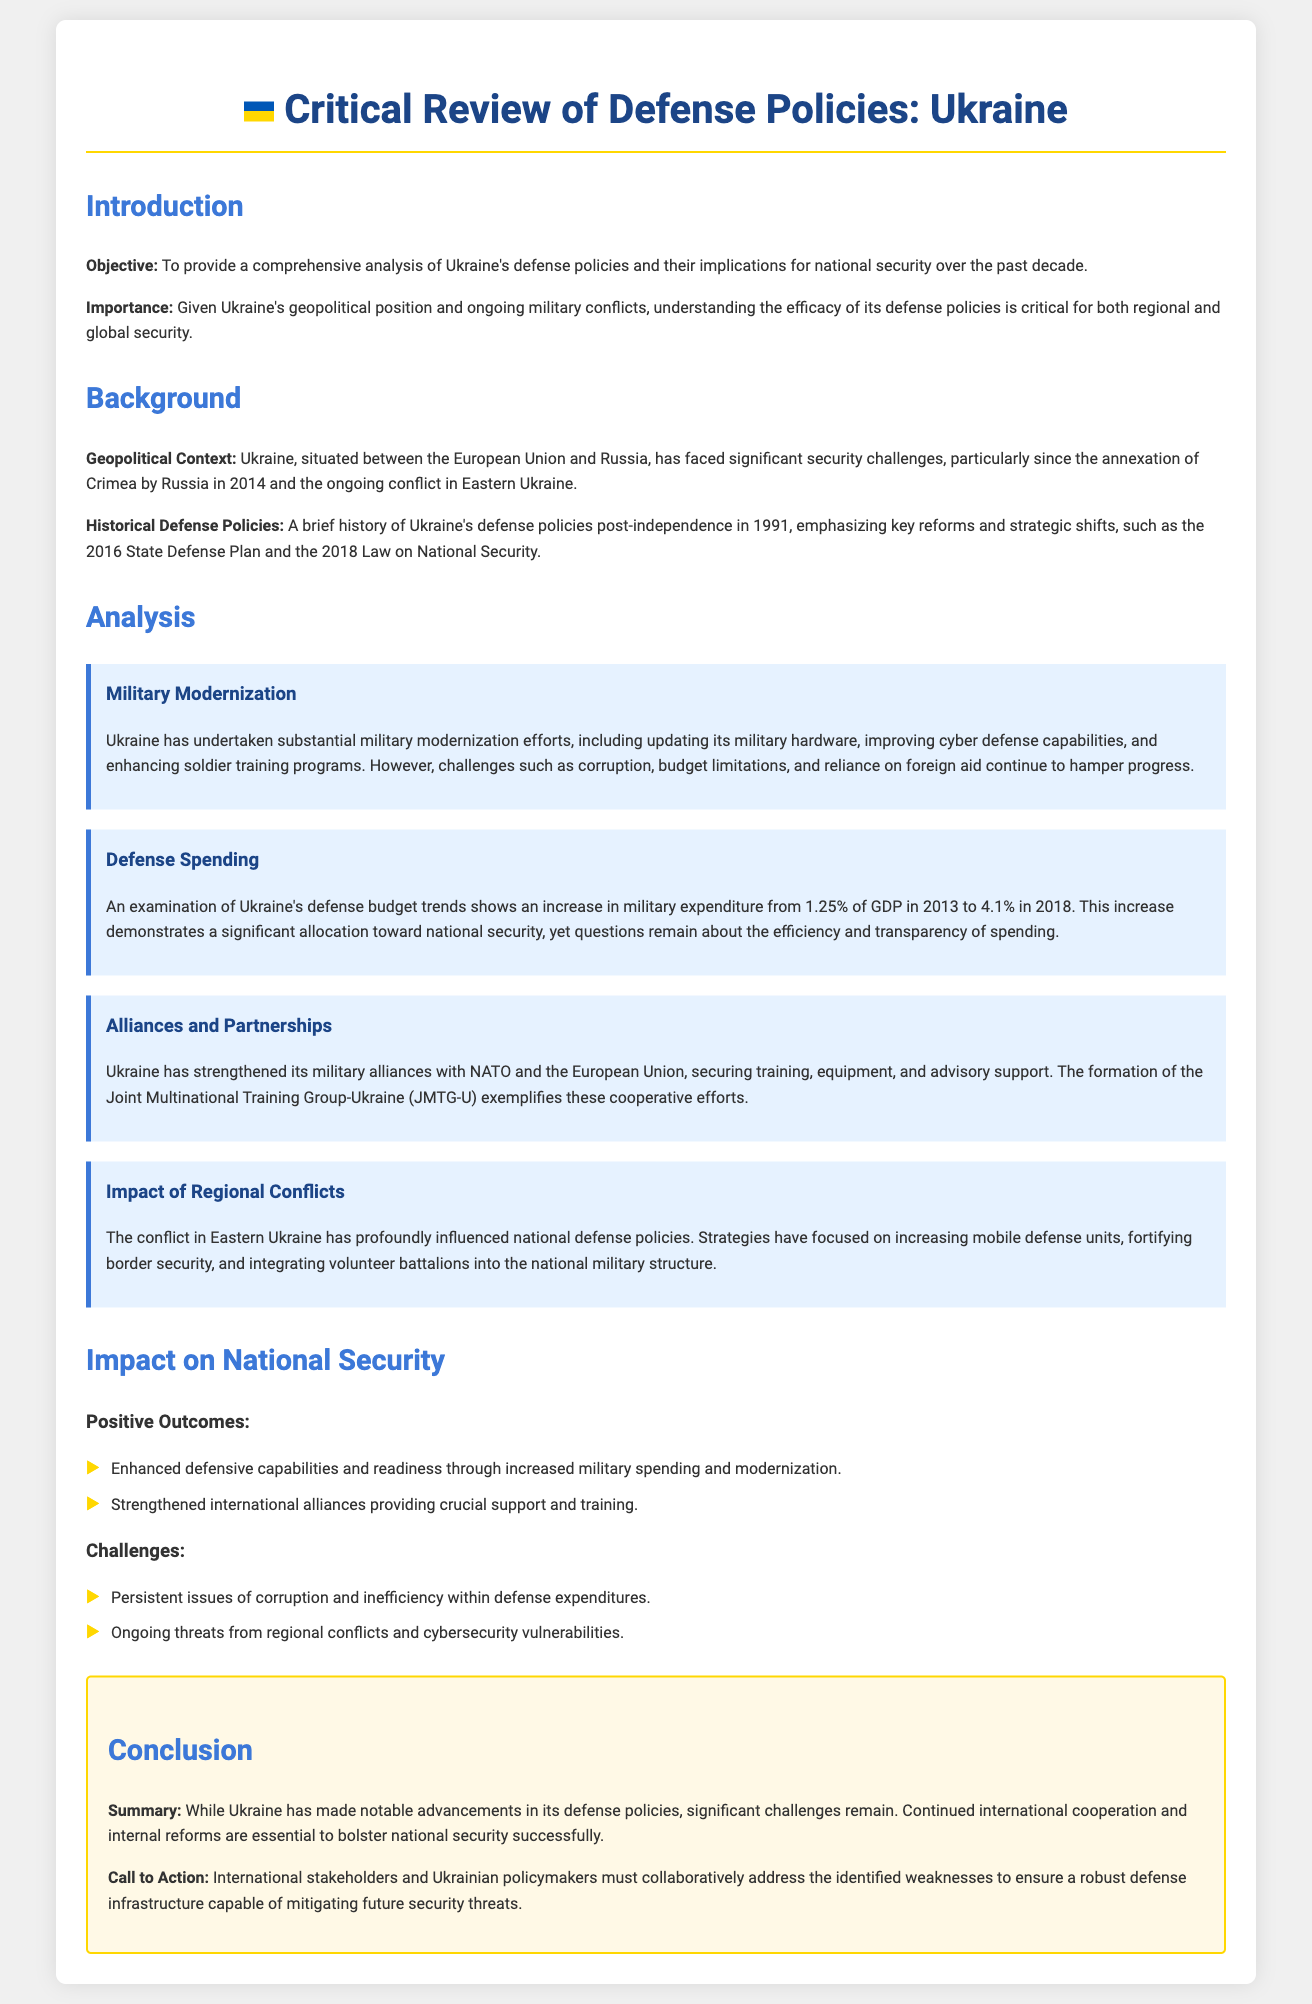what is the objective of the appraisal? The objective is to provide a comprehensive analysis of Ukraine's defense policies and their implications for national security over the past decade.
Answer: To provide a comprehensive analysis of Ukraine's defense policies and their implications for national security over the past decade what year did Ukraine face significant security challenges due to Crimea's annexation? The document states that Crimea was annexed by Russia in 2014, marking a significant security challenge for Ukraine.
Answer: 2014 what is the percentage increase in Ukraine's defense spending from 2013 to 2018? The document notes that defense spending increased from 1.25% of GDP in 2013 to 4.1% in 2018, indicating an increase of 2.85 percentage points.
Answer: 2.85 percentage points which multinational training group has been established to support Ukraine? The document specifies that the Joint Multinational Training Group-Ukraine (JMTG-U) has been formed to support Ukraine's military efforts.
Answer: Joint Multinational Training Group-Ukraine (JMTG-U) what is one of the positive outcomes of Ukraine's defense policies? The document lists enhanced defensive capabilities and readiness as a positive outcome of the defense policies.
Answer: Enhanced defensive capabilities and readiness what are two key challenges mentioned regarding Ukraine's defense policies? The document identifies persistent issues of corruption and inefficiency within defense expenditures as well as ongoing threats from regional conflicts.
Answer: Corruption and inefficiency; regional conflicts what year did the State Defense Plan in Ukraine take effect? The State Defense Plan is referenced in the context of reforms since 2016, indicating it was adopted in that year.
Answer: 2016 what is the call to action mentioned in the conclusion? The call to action emphasizes that international stakeholders and Ukrainian policymakers must collaboratively address identified weaknesses.
Answer: Collaboratively address identified weaknesses 